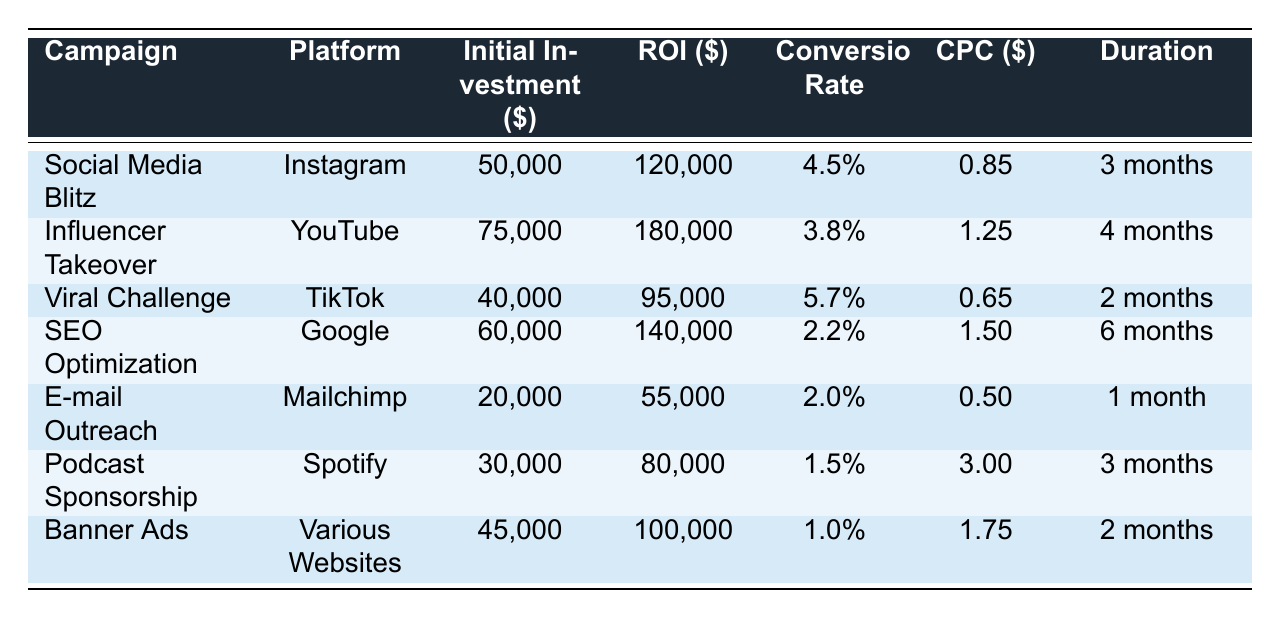What is the total initial investment across all marketing campaigns? To find the total initial investment, we add up all the values in the "Initial Investment" column: 50000 + 75000 + 40000 + 60000 + 20000 + 30000 + 45000 = 320000
Answer: 320000 Which campaign has the highest ROI? By examining the "ROI" column, we find that "Influencer Takeover" has the highest ROI at 180000
Answer: Influencer Takeover Is the conversion rate of the "Social Media Blitz" campaign greater than 5%? The conversion rate for "Social Media Blitz" is 4.5%, which is less than 5%
Answer: No How much more does the "Influencer Takeover" campaign yield in ROI compared to the "E-mail Outreach" campaign? The ROI for "Influencer Takeover" is 180000 and for "E-mail Outreach" is 55000. Thus, the difference is 180000 - 55000 = 125000
Answer: 125000 What is the average cost per click (CPC) of all campaigns? The total CPC is calculated as follows: (0.85 + 1.25 + 0.65 + 1.50 + 0.50 + 3.00 + 1.75) = 9.50. Then divide by the number of campaigns (7): 9.50 / 7 ≈ 1.36
Answer: 1.36 Does the "Viral Challenge" campaign have a lower initial investment than the "SEO Optimization" campaign? "Viral Challenge" has an initial investment of 40000 and "SEO Optimization" has an initial investment of 60000, which shows that "Viral Challenge" is indeed lower
Answer: Yes Which campaign has the longest duration, and what is that duration? Looking at the “Duration” column, "SEO Optimization" has the longest duration of 6 months
Answer: SEO Optimization, 6 months What is the total ROI generated from campaigns targeting the 18-24 age group? The only campaign targeting the 18-24 age group is "Social Media Blitz", which yields an ROI of 120000
Answer: 120000 Is the overall conversion rate of campaigns with an initial investment below $50,000 greater than those with an investment above? The campaigns with an investment below $50000 (Viral Challenge and E-mail Outreach) have conversion rates of 5.7% and 2.0%, respectively, giving an average of (5.7 + 2.0) / 2 = 3.85%. The others (Social Media Blitz, Influencer Takeover, SEO Optimization, Podcast Sponsorship, and Banner Ads) have conversion rates averaging: (4.5 + 3.8 + 2.2 + 1.5 + 1.0) / 5 = 2.4%. Hence, the former is greater
Answer: Yes 